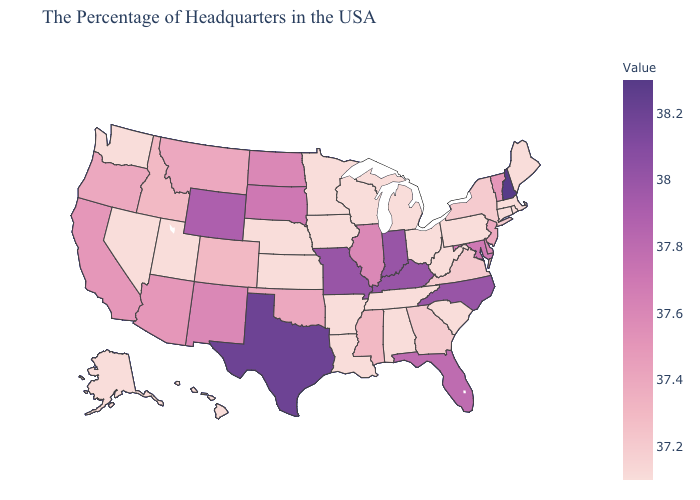Does Louisiana have the highest value in the South?
Concise answer only. No. Which states hav the highest value in the MidWest?
Quick response, please. Indiana, Missouri. Does Oklahoma have the highest value in the South?
Quick response, please. No. 